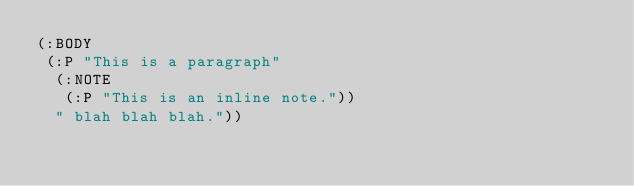<code> <loc_0><loc_0><loc_500><loc_500><_Lisp_>(:BODY
 (:P "This is a paragraph"
  (:NOTE
   (:P "This is an inline note."))
  " blah blah blah."))</code> 